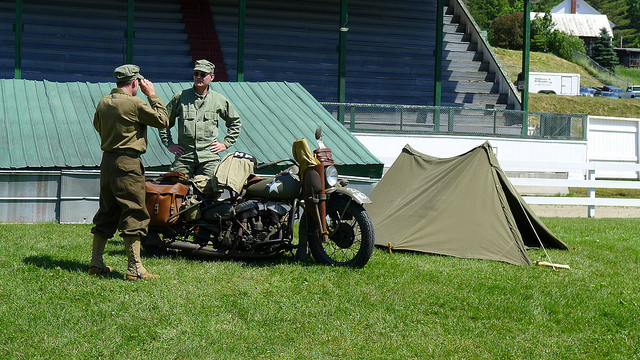What era do the uniforms and motorcycle suggest? The uniforms and motorcycle with a sidecar depicted in the image are reminiscent of those used in the World War II era. Such designs were common among military personnel and vehicles during the 1940s. 